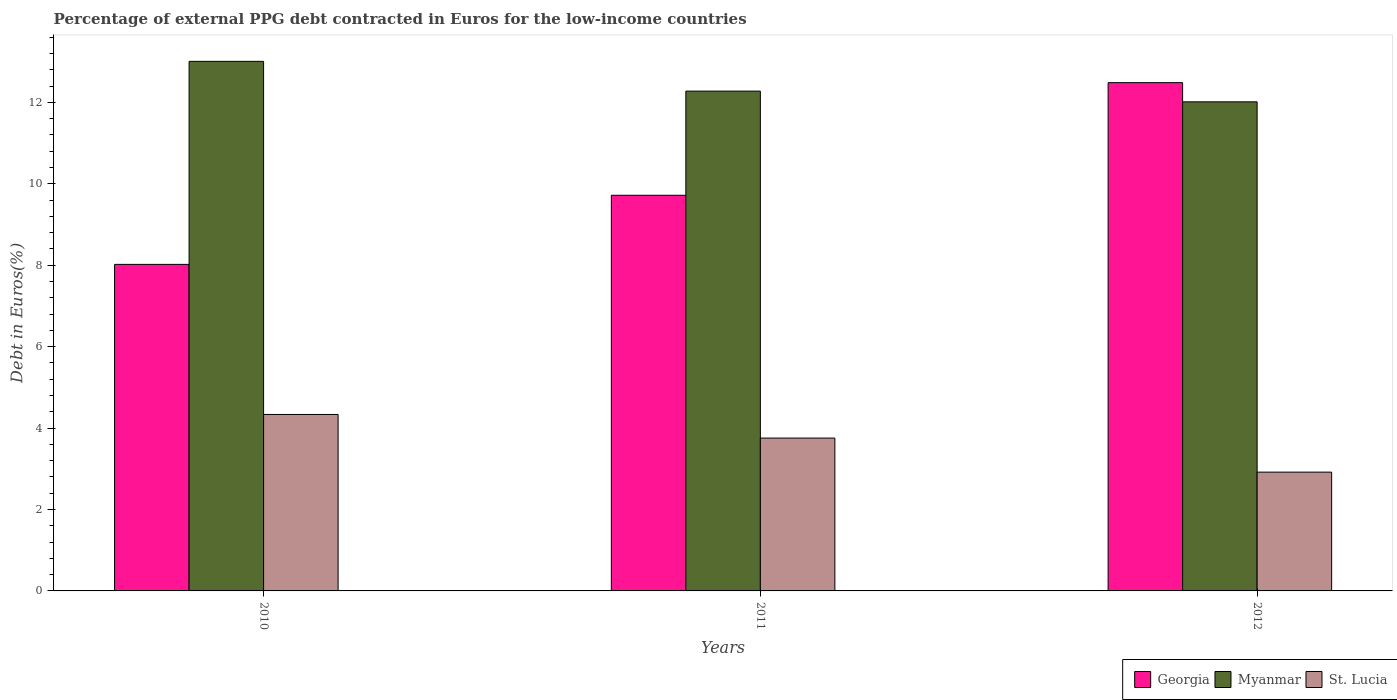What is the label of the 1st group of bars from the left?
Make the answer very short. 2010. In how many cases, is the number of bars for a given year not equal to the number of legend labels?
Provide a succinct answer. 0. What is the percentage of external PPG debt contracted in Euros in Georgia in 2011?
Keep it short and to the point. 9.72. Across all years, what is the maximum percentage of external PPG debt contracted in Euros in St. Lucia?
Your answer should be compact. 4.33. Across all years, what is the minimum percentage of external PPG debt contracted in Euros in Myanmar?
Provide a succinct answer. 12.01. In which year was the percentage of external PPG debt contracted in Euros in Georgia maximum?
Provide a short and direct response. 2012. In which year was the percentage of external PPG debt contracted in Euros in St. Lucia minimum?
Your answer should be compact. 2012. What is the total percentage of external PPG debt contracted in Euros in Myanmar in the graph?
Offer a very short reply. 37.3. What is the difference between the percentage of external PPG debt contracted in Euros in Myanmar in 2010 and that in 2012?
Provide a succinct answer. 0.99. What is the difference between the percentage of external PPG debt contracted in Euros in St. Lucia in 2011 and the percentage of external PPG debt contracted in Euros in Myanmar in 2012?
Offer a terse response. -8.26. What is the average percentage of external PPG debt contracted in Euros in St. Lucia per year?
Ensure brevity in your answer.  3.67. In the year 2011, what is the difference between the percentage of external PPG debt contracted in Euros in Myanmar and percentage of external PPG debt contracted in Euros in St. Lucia?
Give a very brief answer. 8.52. In how many years, is the percentage of external PPG debt contracted in Euros in Myanmar greater than 6 %?
Your answer should be compact. 3. What is the ratio of the percentage of external PPG debt contracted in Euros in St. Lucia in 2011 to that in 2012?
Offer a terse response. 1.29. Is the percentage of external PPG debt contracted in Euros in Myanmar in 2010 less than that in 2012?
Provide a short and direct response. No. Is the difference between the percentage of external PPG debt contracted in Euros in Myanmar in 2010 and 2012 greater than the difference between the percentage of external PPG debt contracted in Euros in St. Lucia in 2010 and 2012?
Ensure brevity in your answer.  No. What is the difference between the highest and the second highest percentage of external PPG debt contracted in Euros in St. Lucia?
Keep it short and to the point. 0.58. What is the difference between the highest and the lowest percentage of external PPG debt contracted in Euros in Georgia?
Give a very brief answer. 4.46. Is the sum of the percentage of external PPG debt contracted in Euros in Myanmar in 2011 and 2012 greater than the maximum percentage of external PPG debt contracted in Euros in St. Lucia across all years?
Make the answer very short. Yes. What does the 2nd bar from the left in 2011 represents?
Your answer should be compact. Myanmar. What does the 3rd bar from the right in 2010 represents?
Keep it short and to the point. Georgia. Is it the case that in every year, the sum of the percentage of external PPG debt contracted in Euros in Myanmar and percentage of external PPG debt contracted in Euros in St. Lucia is greater than the percentage of external PPG debt contracted in Euros in Georgia?
Provide a short and direct response. Yes. How many years are there in the graph?
Offer a very short reply. 3. What is the difference between two consecutive major ticks on the Y-axis?
Keep it short and to the point. 2. Where does the legend appear in the graph?
Offer a terse response. Bottom right. How many legend labels are there?
Offer a terse response. 3. How are the legend labels stacked?
Your answer should be very brief. Horizontal. What is the title of the graph?
Provide a short and direct response. Percentage of external PPG debt contracted in Euros for the low-income countries. Does "France" appear as one of the legend labels in the graph?
Your answer should be very brief. No. What is the label or title of the Y-axis?
Offer a very short reply. Debt in Euros(%). What is the Debt in Euros(%) of Georgia in 2010?
Provide a succinct answer. 8.02. What is the Debt in Euros(%) in Myanmar in 2010?
Your response must be concise. 13.01. What is the Debt in Euros(%) of St. Lucia in 2010?
Provide a succinct answer. 4.33. What is the Debt in Euros(%) of Georgia in 2011?
Provide a succinct answer. 9.72. What is the Debt in Euros(%) of Myanmar in 2011?
Ensure brevity in your answer.  12.28. What is the Debt in Euros(%) of St. Lucia in 2011?
Provide a succinct answer. 3.75. What is the Debt in Euros(%) in Georgia in 2012?
Offer a very short reply. 12.48. What is the Debt in Euros(%) in Myanmar in 2012?
Give a very brief answer. 12.01. What is the Debt in Euros(%) in St. Lucia in 2012?
Keep it short and to the point. 2.92. Across all years, what is the maximum Debt in Euros(%) in Georgia?
Your response must be concise. 12.48. Across all years, what is the maximum Debt in Euros(%) in Myanmar?
Ensure brevity in your answer.  13.01. Across all years, what is the maximum Debt in Euros(%) of St. Lucia?
Give a very brief answer. 4.33. Across all years, what is the minimum Debt in Euros(%) in Georgia?
Your response must be concise. 8.02. Across all years, what is the minimum Debt in Euros(%) of Myanmar?
Keep it short and to the point. 12.01. Across all years, what is the minimum Debt in Euros(%) in St. Lucia?
Offer a terse response. 2.92. What is the total Debt in Euros(%) of Georgia in the graph?
Make the answer very short. 30.22. What is the total Debt in Euros(%) in Myanmar in the graph?
Make the answer very short. 37.3. What is the total Debt in Euros(%) of St. Lucia in the graph?
Ensure brevity in your answer.  11.01. What is the difference between the Debt in Euros(%) of Georgia in 2010 and that in 2011?
Give a very brief answer. -1.7. What is the difference between the Debt in Euros(%) of Myanmar in 2010 and that in 2011?
Keep it short and to the point. 0.73. What is the difference between the Debt in Euros(%) in St. Lucia in 2010 and that in 2011?
Provide a short and direct response. 0.58. What is the difference between the Debt in Euros(%) in Georgia in 2010 and that in 2012?
Ensure brevity in your answer.  -4.46. What is the difference between the Debt in Euros(%) in Myanmar in 2010 and that in 2012?
Keep it short and to the point. 0.99. What is the difference between the Debt in Euros(%) of St. Lucia in 2010 and that in 2012?
Your answer should be very brief. 1.42. What is the difference between the Debt in Euros(%) in Georgia in 2011 and that in 2012?
Ensure brevity in your answer.  -2.77. What is the difference between the Debt in Euros(%) in Myanmar in 2011 and that in 2012?
Offer a terse response. 0.26. What is the difference between the Debt in Euros(%) of St. Lucia in 2011 and that in 2012?
Provide a succinct answer. 0.84. What is the difference between the Debt in Euros(%) in Georgia in 2010 and the Debt in Euros(%) in Myanmar in 2011?
Keep it short and to the point. -4.26. What is the difference between the Debt in Euros(%) of Georgia in 2010 and the Debt in Euros(%) of St. Lucia in 2011?
Provide a short and direct response. 4.27. What is the difference between the Debt in Euros(%) in Myanmar in 2010 and the Debt in Euros(%) in St. Lucia in 2011?
Your answer should be very brief. 9.25. What is the difference between the Debt in Euros(%) of Georgia in 2010 and the Debt in Euros(%) of Myanmar in 2012?
Make the answer very short. -3.99. What is the difference between the Debt in Euros(%) of Georgia in 2010 and the Debt in Euros(%) of St. Lucia in 2012?
Your response must be concise. 5.1. What is the difference between the Debt in Euros(%) of Myanmar in 2010 and the Debt in Euros(%) of St. Lucia in 2012?
Keep it short and to the point. 10.09. What is the difference between the Debt in Euros(%) in Georgia in 2011 and the Debt in Euros(%) in Myanmar in 2012?
Make the answer very short. -2.29. What is the difference between the Debt in Euros(%) in Georgia in 2011 and the Debt in Euros(%) in St. Lucia in 2012?
Keep it short and to the point. 6.8. What is the difference between the Debt in Euros(%) in Myanmar in 2011 and the Debt in Euros(%) in St. Lucia in 2012?
Your response must be concise. 9.36. What is the average Debt in Euros(%) of Georgia per year?
Ensure brevity in your answer.  10.07. What is the average Debt in Euros(%) of Myanmar per year?
Your response must be concise. 12.43. What is the average Debt in Euros(%) in St. Lucia per year?
Make the answer very short. 3.67. In the year 2010, what is the difference between the Debt in Euros(%) in Georgia and Debt in Euros(%) in Myanmar?
Provide a short and direct response. -4.99. In the year 2010, what is the difference between the Debt in Euros(%) in Georgia and Debt in Euros(%) in St. Lucia?
Provide a short and direct response. 3.69. In the year 2010, what is the difference between the Debt in Euros(%) in Myanmar and Debt in Euros(%) in St. Lucia?
Provide a succinct answer. 8.67. In the year 2011, what is the difference between the Debt in Euros(%) of Georgia and Debt in Euros(%) of Myanmar?
Offer a very short reply. -2.56. In the year 2011, what is the difference between the Debt in Euros(%) of Georgia and Debt in Euros(%) of St. Lucia?
Offer a very short reply. 5.96. In the year 2011, what is the difference between the Debt in Euros(%) in Myanmar and Debt in Euros(%) in St. Lucia?
Offer a very short reply. 8.52. In the year 2012, what is the difference between the Debt in Euros(%) in Georgia and Debt in Euros(%) in Myanmar?
Ensure brevity in your answer.  0.47. In the year 2012, what is the difference between the Debt in Euros(%) in Georgia and Debt in Euros(%) in St. Lucia?
Ensure brevity in your answer.  9.57. In the year 2012, what is the difference between the Debt in Euros(%) of Myanmar and Debt in Euros(%) of St. Lucia?
Offer a very short reply. 9.1. What is the ratio of the Debt in Euros(%) of Georgia in 2010 to that in 2011?
Give a very brief answer. 0.83. What is the ratio of the Debt in Euros(%) of Myanmar in 2010 to that in 2011?
Offer a terse response. 1.06. What is the ratio of the Debt in Euros(%) of St. Lucia in 2010 to that in 2011?
Your answer should be very brief. 1.15. What is the ratio of the Debt in Euros(%) in Georgia in 2010 to that in 2012?
Your answer should be very brief. 0.64. What is the ratio of the Debt in Euros(%) in Myanmar in 2010 to that in 2012?
Your answer should be compact. 1.08. What is the ratio of the Debt in Euros(%) in St. Lucia in 2010 to that in 2012?
Ensure brevity in your answer.  1.49. What is the ratio of the Debt in Euros(%) of Georgia in 2011 to that in 2012?
Keep it short and to the point. 0.78. What is the ratio of the Debt in Euros(%) in Myanmar in 2011 to that in 2012?
Offer a terse response. 1.02. What is the ratio of the Debt in Euros(%) in St. Lucia in 2011 to that in 2012?
Keep it short and to the point. 1.29. What is the difference between the highest and the second highest Debt in Euros(%) of Georgia?
Your response must be concise. 2.77. What is the difference between the highest and the second highest Debt in Euros(%) in Myanmar?
Offer a very short reply. 0.73. What is the difference between the highest and the second highest Debt in Euros(%) of St. Lucia?
Ensure brevity in your answer.  0.58. What is the difference between the highest and the lowest Debt in Euros(%) of Georgia?
Your answer should be very brief. 4.46. What is the difference between the highest and the lowest Debt in Euros(%) in St. Lucia?
Make the answer very short. 1.42. 